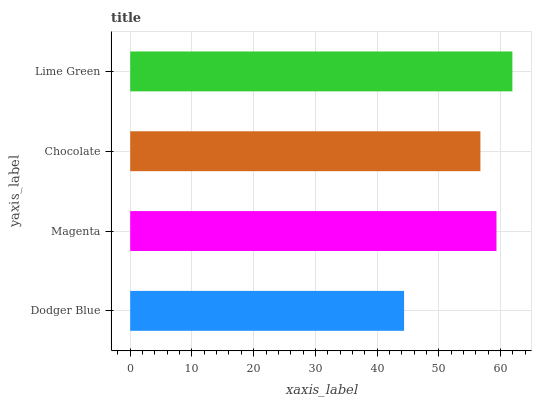Is Dodger Blue the minimum?
Answer yes or no. Yes. Is Lime Green the maximum?
Answer yes or no. Yes. Is Magenta the minimum?
Answer yes or no. No. Is Magenta the maximum?
Answer yes or no. No. Is Magenta greater than Dodger Blue?
Answer yes or no. Yes. Is Dodger Blue less than Magenta?
Answer yes or no. Yes. Is Dodger Blue greater than Magenta?
Answer yes or no. No. Is Magenta less than Dodger Blue?
Answer yes or no. No. Is Magenta the high median?
Answer yes or no. Yes. Is Chocolate the low median?
Answer yes or no. Yes. Is Chocolate the high median?
Answer yes or no. No. Is Lime Green the low median?
Answer yes or no. No. 